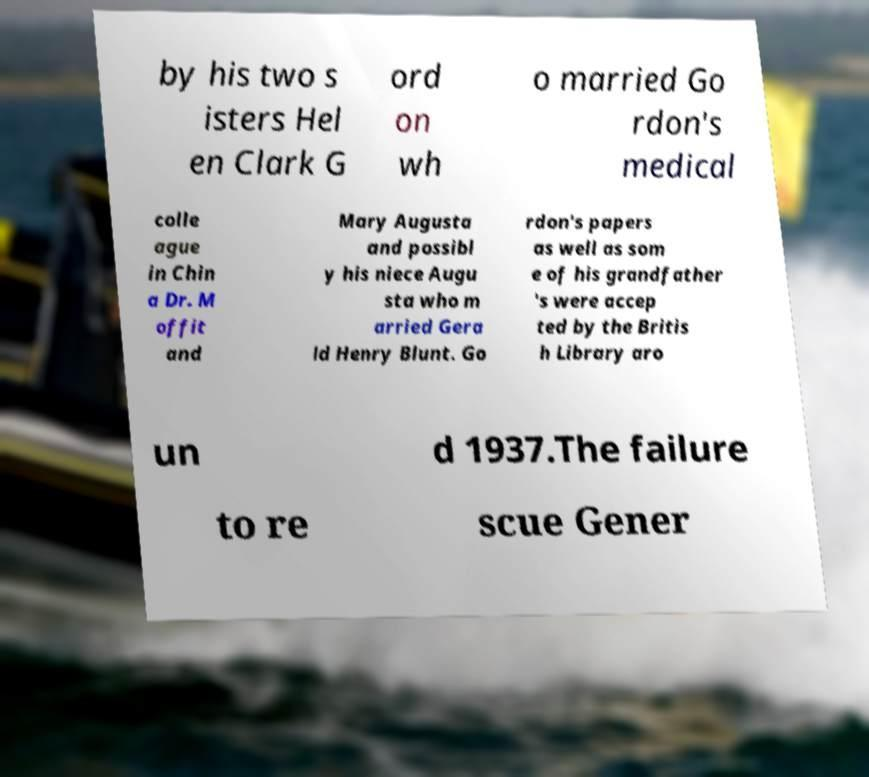There's text embedded in this image that I need extracted. Can you transcribe it verbatim? by his two s isters Hel en Clark G ord on wh o married Go rdon's medical colle ague in Chin a Dr. M offit and Mary Augusta and possibl y his niece Augu sta who m arried Gera ld Henry Blunt. Go rdon's papers as well as som e of his grandfather 's were accep ted by the Britis h Library aro un d 1937.The failure to re scue Gener 